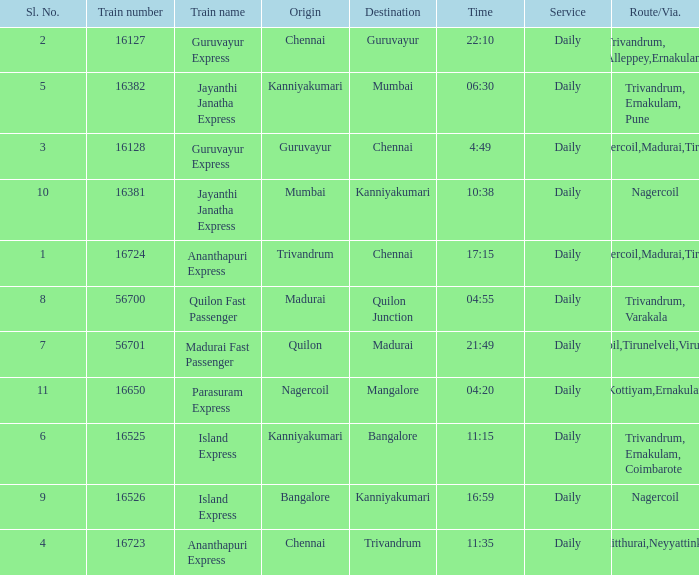What is the train number when the time is 10:38? 16381.0. Could you parse the entire table as a dict? {'header': ['Sl. No.', 'Train number', 'Train name', 'Origin', 'Destination', 'Time', 'Service', 'Route/Via.'], 'rows': [['2', '16127', 'Guruvayur Express', 'Chennai', 'Guruvayur', '22:10', 'Daily', 'Trivandrum, Alleppey,Ernakulam'], ['5', '16382', 'Jayanthi Janatha Express', 'Kanniyakumari', 'Mumbai', '06:30', 'Daily', 'Trivandrum, Ernakulam, Pune'], ['3', '16128', 'Guruvayur Express', 'Guruvayur', 'Chennai', '4:49', 'Daily', 'Nagercoil,Madurai,Tiruchi'], ['10', '16381', 'Jayanthi Janatha Express', 'Mumbai', 'Kanniyakumari', '10:38', 'Daily', 'Nagercoil'], ['1', '16724', 'Ananthapuri Express', 'Trivandrum', 'Chennai', '17:15', 'Daily', 'Nagercoil,Madurai,Tiruchi'], ['8', '56700', 'Quilon Fast Passenger', 'Madurai', 'Quilon Junction', '04:55', 'Daily', 'Trivandrum, Varakala'], ['7', '56701', 'Madurai Fast Passenger', 'Quilon', 'Madurai', '21:49', 'Daily', 'Nagercoil,Tirunelveli,Virudunagar'], ['11', '16650', 'Parasuram Express', 'Nagercoil', 'Mangalore', '04:20', 'Daily', 'Trivandrum,Kottiyam,Ernakulam,Kozhikode'], ['6', '16525', 'Island Express', 'Kanniyakumari', 'Bangalore', '11:15', 'Daily', 'Trivandrum, Ernakulam, Coimbarote'], ['9', '16526', 'Island Express', 'Bangalore', 'Kanniyakumari', '16:59', 'Daily', 'Nagercoil'], ['4', '16723', 'Ananthapuri Express', 'Chennai', 'Trivandrum', '11:35', 'Daily', 'Kulitthurai,Neyyattinkara']]} 